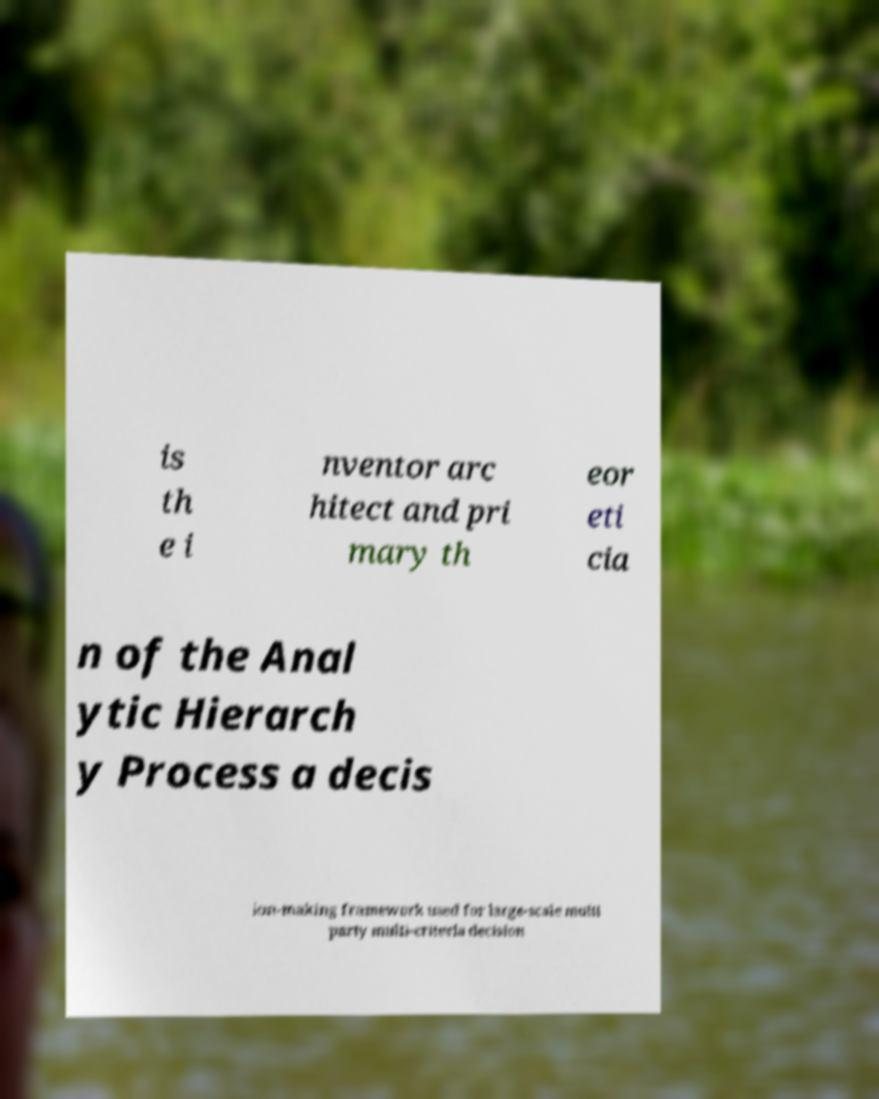Can you read and provide the text displayed in the image?This photo seems to have some interesting text. Can you extract and type it out for me? is th e i nventor arc hitect and pri mary th eor eti cia n of the Anal ytic Hierarch y Process a decis ion-making framework used for large-scale multi party multi-criteria decision 